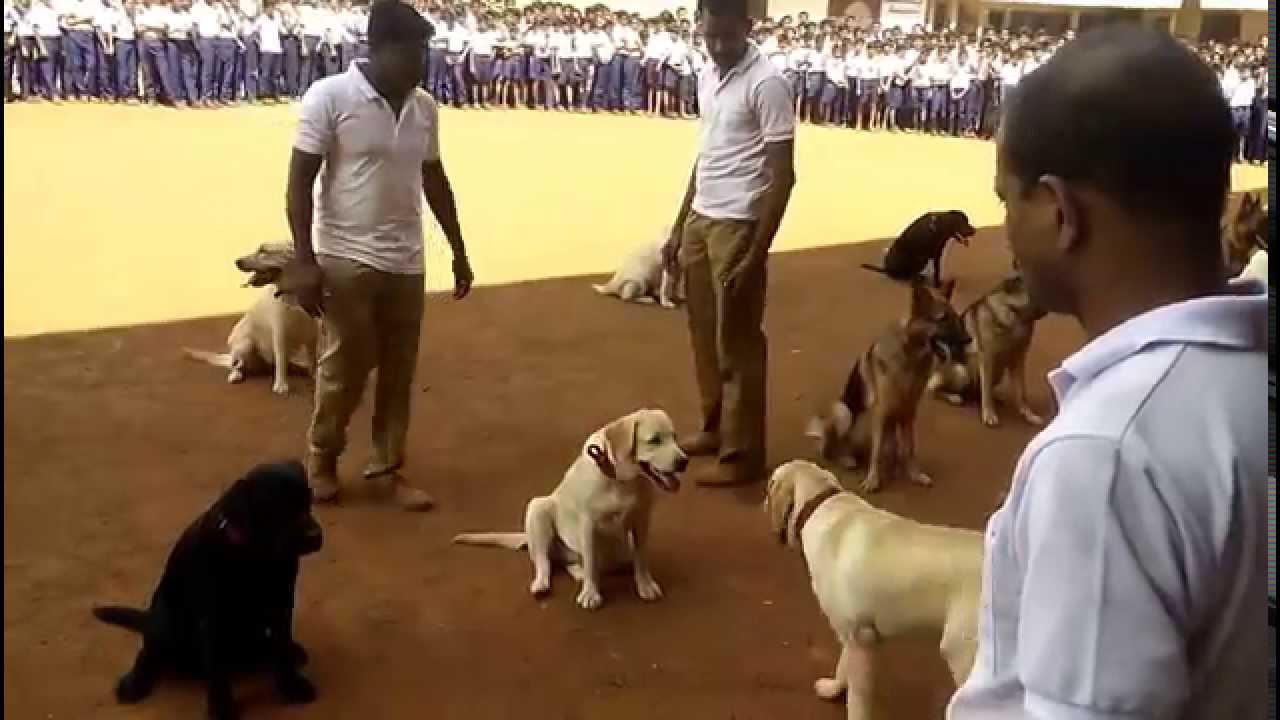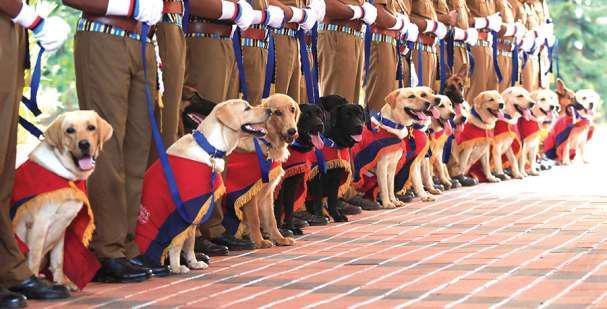The first image is the image on the left, the second image is the image on the right. For the images displayed, is the sentence "In one of the images, only one dog is present." factually correct? Answer yes or no. No. The first image is the image on the left, the second image is the image on the right. Examine the images to the left and right. Is the description "At least one dog is sitting." accurate? Answer yes or no. Yes. 